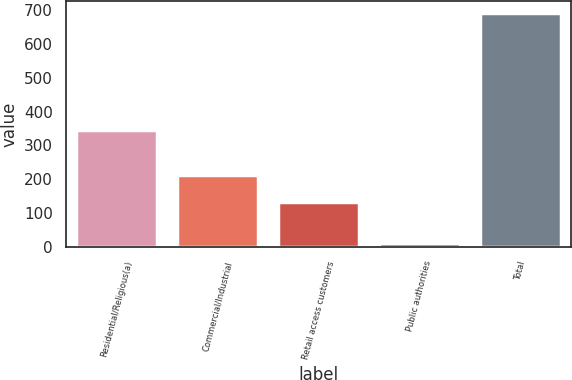<chart> <loc_0><loc_0><loc_500><loc_500><bar_chart><fcel>Residential/Religious(a)<fcel>Commercial/Industrial<fcel>Retail access customers<fcel>Public authorities<fcel>Total<nl><fcel>347<fcel>211<fcel>132<fcel>12<fcel>692<nl></chart> 